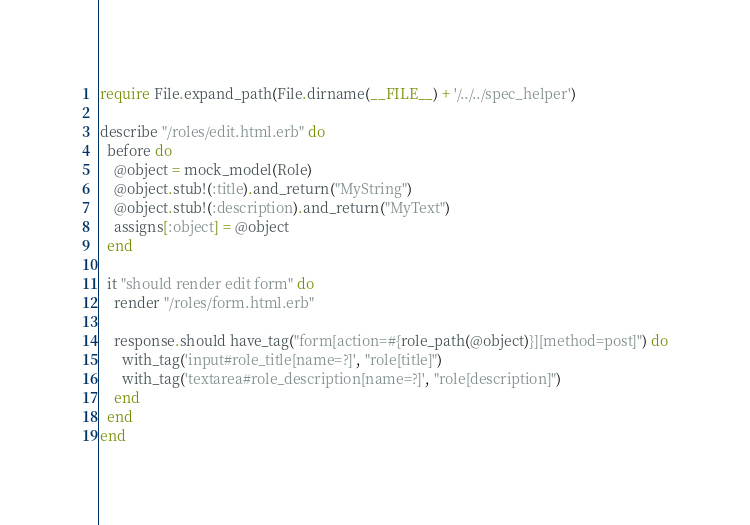<code> <loc_0><loc_0><loc_500><loc_500><_Ruby_>require File.expand_path(File.dirname(__FILE__) + '/../../spec_helper')

describe "/roles/edit.html.erb" do
  before do
    @object = mock_model(Role)
    @object.stub!(:title).and_return("MyString")
    @object.stub!(:description).and_return("MyText")
    assigns[:object] = @object
  end

  it "should render edit form" do
    render "/roles/form.html.erb"
    
    response.should have_tag("form[action=#{role_path(@object)}][method=post]") do
      with_tag('input#role_title[name=?]', "role[title]")
      with_tag('textarea#role_description[name=?]', "role[description]")
    end
  end
end


</code> 